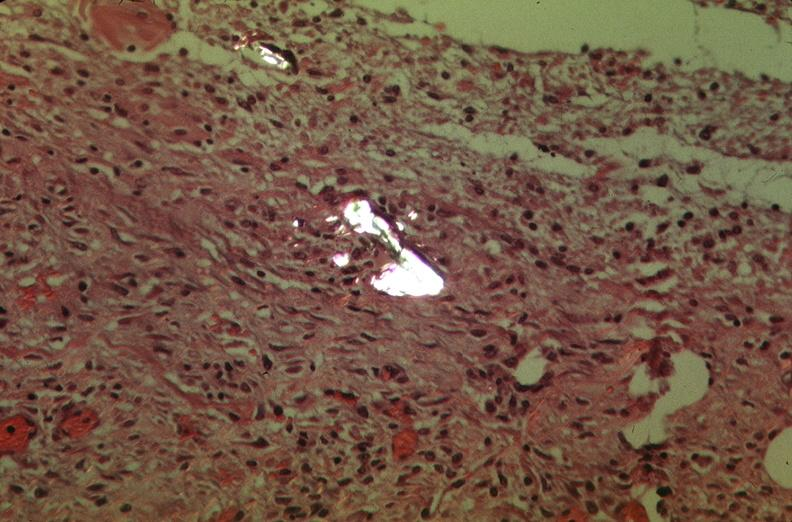what was used to sclerose emphysematous lung, alpha-1 antitrypsin deficiency?
Answer the question using a single word or phrase. Talc 